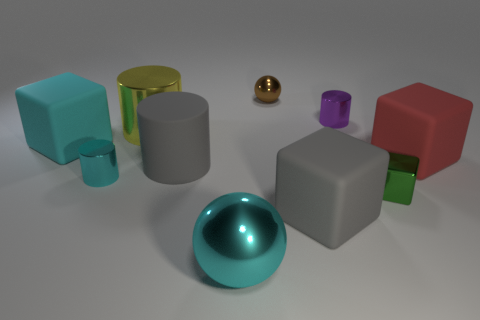Are there fewer big cyan matte cylinders than large cyan rubber blocks?
Provide a short and direct response. Yes. There is a big rubber cube in front of the tiny cyan cylinder; is its color the same as the rubber cylinder?
Give a very brief answer. Yes. What number of cylinders are the same size as the red thing?
Make the answer very short. 2. Is there a object that has the same color as the big rubber cylinder?
Provide a succinct answer. Yes. Do the brown thing and the large gray block have the same material?
Make the answer very short. No. How many yellow metallic objects have the same shape as the purple thing?
Your answer should be very brief. 1. The green object that is made of the same material as the tiny brown sphere is what shape?
Your answer should be compact. Cube. What color is the large shiny thing behind the big cyan thing that is in front of the cyan metal cylinder?
Offer a terse response. Yellow. What material is the small cylinder in front of the cylinder that is behind the yellow shiny thing made of?
Ensure brevity in your answer.  Metal. There is a tiny green object that is the same shape as the large cyan matte thing; what is it made of?
Ensure brevity in your answer.  Metal. 